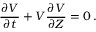Convert formula to latex. <formula><loc_0><loc_0><loc_500><loc_500>\frac { \partial V } { \partial t } + V \frac { \partial V } { \partial Z } = 0 \, .</formula> 